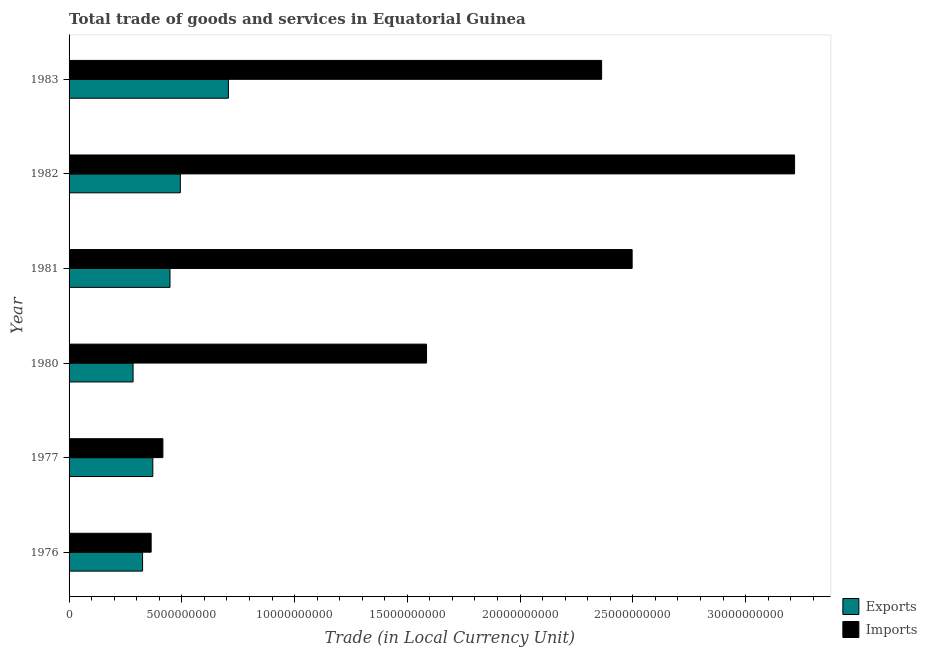How many groups of bars are there?
Your response must be concise. 6. How many bars are there on the 3rd tick from the top?
Ensure brevity in your answer.  2. What is the label of the 5th group of bars from the top?
Offer a very short reply. 1977. In how many cases, is the number of bars for a given year not equal to the number of legend labels?
Offer a very short reply. 0. What is the export of goods and services in 1977?
Keep it short and to the point. 3.71e+09. Across all years, what is the maximum export of goods and services?
Keep it short and to the point. 7.07e+09. Across all years, what is the minimum imports of goods and services?
Make the answer very short. 3.64e+09. In which year was the imports of goods and services minimum?
Your answer should be compact. 1976. What is the total export of goods and services in the graph?
Your response must be concise. 2.63e+1. What is the difference between the export of goods and services in 1976 and that in 1983?
Your answer should be compact. -3.81e+09. What is the difference between the imports of goods and services in 1983 and the export of goods and services in 1982?
Keep it short and to the point. 1.87e+1. What is the average export of goods and services per year?
Offer a very short reply. 4.38e+09. In the year 1981, what is the difference between the imports of goods and services and export of goods and services?
Provide a succinct answer. 2.05e+1. In how many years, is the imports of goods and services greater than 32000000000 LCU?
Your answer should be compact. 1. What is the ratio of the export of goods and services in 1976 to that in 1980?
Provide a succinct answer. 1.15. Is the export of goods and services in 1976 less than that in 1981?
Offer a terse response. Yes. Is the difference between the imports of goods and services in 1976 and 1981 greater than the difference between the export of goods and services in 1976 and 1981?
Give a very brief answer. No. What is the difference between the highest and the second highest export of goods and services?
Give a very brief answer. 2.13e+09. What is the difference between the highest and the lowest export of goods and services?
Provide a succinct answer. 4.23e+09. What does the 2nd bar from the top in 1977 represents?
Provide a succinct answer. Exports. What does the 1st bar from the bottom in 1980 represents?
Your answer should be very brief. Exports. Are all the bars in the graph horizontal?
Keep it short and to the point. Yes. Does the graph contain any zero values?
Offer a very short reply. No. Does the graph contain grids?
Your response must be concise. No. Where does the legend appear in the graph?
Offer a terse response. Bottom right. How are the legend labels stacked?
Offer a very short reply. Vertical. What is the title of the graph?
Your response must be concise. Total trade of goods and services in Equatorial Guinea. Does "Resident workers" appear as one of the legend labels in the graph?
Provide a short and direct response. No. What is the label or title of the X-axis?
Provide a short and direct response. Trade (in Local Currency Unit). What is the Trade (in Local Currency Unit) in Exports in 1976?
Offer a very short reply. 3.26e+09. What is the Trade (in Local Currency Unit) in Imports in 1976?
Provide a succinct answer. 3.64e+09. What is the Trade (in Local Currency Unit) in Exports in 1977?
Your answer should be very brief. 3.71e+09. What is the Trade (in Local Currency Unit) in Imports in 1977?
Keep it short and to the point. 4.16e+09. What is the Trade (in Local Currency Unit) in Exports in 1980?
Your answer should be compact. 2.84e+09. What is the Trade (in Local Currency Unit) of Imports in 1980?
Your response must be concise. 1.59e+1. What is the Trade (in Local Currency Unit) of Exports in 1981?
Provide a succinct answer. 4.48e+09. What is the Trade (in Local Currency Unit) in Imports in 1981?
Offer a terse response. 2.50e+1. What is the Trade (in Local Currency Unit) in Exports in 1982?
Ensure brevity in your answer.  4.93e+09. What is the Trade (in Local Currency Unit) in Imports in 1982?
Your answer should be compact. 3.22e+1. What is the Trade (in Local Currency Unit) of Exports in 1983?
Keep it short and to the point. 7.07e+09. What is the Trade (in Local Currency Unit) of Imports in 1983?
Your response must be concise. 2.36e+1. Across all years, what is the maximum Trade (in Local Currency Unit) in Exports?
Offer a terse response. 7.07e+09. Across all years, what is the maximum Trade (in Local Currency Unit) in Imports?
Your answer should be very brief. 3.22e+1. Across all years, what is the minimum Trade (in Local Currency Unit) in Exports?
Offer a terse response. 2.84e+09. Across all years, what is the minimum Trade (in Local Currency Unit) of Imports?
Give a very brief answer. 3.64e+09. What is the total Trade (in Local Currency Unit) of Exports in the graph?
Your answer should be very brief. 2.63e+1. What is the total Trade (in Local Currency Unit) in Imports in the graph?
Give a very brief answer. 1.04e+11. What is the difference between the Trade (in Local Currency Unit) of Exports in 1976 and that in 1977?
Provide a succinct answer. -4.54e+08. What is the difference between the Trade (in Local Currency Unit) in Imports in 1976 and that in 1977?
Provide a succinct answer. -5.21e+08. What is the difference between the Trade (in Local Currency Unit) in Exports in 1976 and that in 1980?
Offer a terse response. 4.21e+08. What is the difference between the Trade (in Local Currency Unit) of Imports in 1976 and that in 1980?
Provide a succinct answer. -1.22e+1. What is the difference between the Trade (in Local Currency Unit) in Exports in 1976 and that in 1981?
Provide a succinct answer. -1.22e+09. What is the difference between the Trade (in Local Currency Unit) of Imports in 1976 and that in 1981?
Make the answer very short. -2.13e+1. What is the difference between the Trade (in Local Currency Unit) in Exports in 1976 and that in 1982?
Your answer should be compact. -1.67e+09. What is the difference between the Trade (in Local Currency Unit) of Imports in 1976 and that in 1982?
Ensure brevity in your answer.  -2.85e+1. What is the difference between the Trade (in Local Currency Unit) of Exports in 1976 and that in 1983?
Your answer should be compact. -3.81e+09. What is the difference between the Trade (in Local Currency Unit) in Imports in 1976 and that in 1983?
Offer a very short reply. -2.00e+1. What is the difference between the Trade (in Local Currency Unit) in Exports in 1977 and that in 1980?
Offer a terse response. 8.75e+08. What is the difference between the Trade (in Local Currency Unit) in Imports in 1977 and that in 1980?
Give a very brief answer. -1.17e+1. What is the difference between the Trade (in Local Currency Unit) of Exports in 1977 and that in 1981?
Ensure brevity in your answer.  -7.62e+08. What is the difference between the Trade (in Local Currency Unit) in Imports in 1977 and that in 1981?
Your answer should be compact. -2.08e+1. What is the difference between the Trade (in Local Currency Unit) in Exports in 1977 and that in 1982?
Your answer should be compact. -1.22e+09. What is the difference between the Trade (in Local Currency Unit) in Imports in 1977 and that in 1982?
Offer a very short reply. -2.80e+1. What is the difference between the Trade (in Local Currency Unit) of Exports in 1977 and that in 1983?
Provide a succinct answer. -3.35e+09. What is the difference between the Trade (in Local Currency Unit) in Imports in 1977 and that in 1983?
Make the answer very short. -1.95e+1. What is the difference between the Trade (in Local Currency Unit) of Exports in 1980 and that in 1981?
Keep it short and to the point. -1.64e+09. What is the difference between the Trade (in Local Currency Unit) of Imports in 1980 and that in 1981?
Your answer should be very brief. -9.12e+09. What is the difference between the Trade (in Local Currency Unit) of Exports in 1980 and that in 1982?
Make the answer very short. -2.10e+09. What is the difference between the Trade (in Local Currency Unit) in Imports in 1980 and that in 1982?
Your answer should be compact. -1.63e+1. What is the difference between the Trade (in Local Currency Unit) in Exports in 1980 and that in 1983?
Your answer should be very brief. -4.23e+09. What is the difference between the Trade (in Local Currency Unit) of Imports in 1980 and that in 1983?
Give a very brief answer. -7.76e+09. What is the difference between the Trade (in Local Currency Unit) of Exports in 1981 and that in 1982?
Keep it short and to the point. -4.58e+08. What is the difference between the Trade (in Local Currency Unit) of Imports in 1981 and that in 1982?
Keep it short and to the point. -7.20e+09. What is the difference between the Trade (in Local Currency Unit) of Exports in 1981 and that in 1983?
Ensure brevity in your answer.  -2.59e+09. What is the difference between the Trade (in Local Currency Unit) in Imports in 1981 and that in 1983?
Provide a succinct answer. 1.35e+09. What is the difference between the Trade (in Local Currency Unit) in Exports in 1982 and that in 1983?
Your answer should be compact. -2.13e+09. What is the difference between the Trade (in Local Currency Unit) in Imports in 1982 and that in 1983?
Provide a short and direct response. 8.56e+09. What is the difference between the Trade (in Local Currency Unit) in Exports in 1976 and the Trade (in Local Currency Unit) in Imports in 1977?
Give a very brief answer. -9.01e+08. What is the difference between the Trade (in Local Currency Unit) of Exports in 1976 and the Trade (in Local Currency Unit) of Imports in 1980?
Your answer should be very brief. -1.26e+1. What is the difference between the Trade (in Local Currency Unit) in Exports in 1976 and the Trade (in Local Currency Unit) in Imports in 1981?
Provide a succinct answer. -2.17e+1. What is the difference between the Trade (in Local Currency Unit) of Exports in 1976 and the Trade (in Local Currency Unit) of Imports in 1982?
Your answer should be very brief. -2.89e+1. What is the difference between the Trade (in Local Currency Unit) of Exports in 1976 and the Trade (in Local Currency Unit) of Imports in 1983?
Provide a short and direct response. -2.04e+1. What is the difference between the Trade (in Local Currency Unit) in Exports in 1977 and the Trade (in Local Currency Unit) in Imports in 1980?
Offer a terse response. -1.21e+1. What is the difference between the Trade (in Local Currency Unit) of Exports in 1977 and the Trade (in Local Currency Unit) of Imports in 1981?
Provide a succinct answer. -2.13e+1. What is the difference between the Trade (in Local Currency Unit) of Exports in 1977 and the Trade (in Local Currency Unit) of Imports in 1982?
Your answer should be very brief. -2.85e+1. What is the difference between the Trade (in Local Currency Unit) of Exports in 1977 and the Trade (in Local Currency Unit) of Imports in 1983?
Provide a short and direct response. -1.99e+1. What is the difference between the Trade (in Local Currency Unit) of Exports in 1980 and the Trade (in Local Currency Unit) of Imports in 1981?
Provide a succinct answer. -2.21e+1. What is the difference between the Trade (in Local Currency Unit) of Exports in 1980 and the Trade (in Local Currency Unit) of Imports in 1982?
Make the answer very short. -2.93e+1. What is the difference between the Trade (in Local Currency Unit) in Exports in 1980 and the Trade (in Local Currency Unit) in Imports in 1983?
Provide a short and direct response. -2.08e+1. What is the difference between the Trade (in Local Currency Unit) of Exports in 1981 and the Trade (in Local Currency Unit) of Imports in 1982?
Ensure brevity in your answer.  -2.77e+1. What is the difference between the Trade (in Local Currency Unit) of Exports in 1981 and the Trade (in Local Currency Unit) of Imports in 1983?
Provide a succinct answer. -1.91e+1. What is the difference between the Trade (in Local Currency Unit) of Exports in 1982 and the Trade (in Local Currency Unit) of Imports in 1983?
Give a very brief answer. -1.87e+1. What is the average Trade (in Local Currency Unit) in Exports per year?
Make the answer very short. 4.38e+09. What is the average Trade (in Local Currency Unit) in Imports per year?
Your answer should be compact. 1.74e+1. In the year 1976, what is the difference between the Trade (in Local Currency Unit) of Exports and Trade (in Local Currency Unit) of Imports?
Keep it short and to the point. -3.80e+08. In the year 1977, what is the difference between the Trade (in Local Currency Unit) in Exports and Trade (in Local Currency Unit) in Imports?
Provide a succinct answer. -4.47e+08. In the year 1980, what is the difference between the Trade (in Local Currency Unit) in Exports and Trade (in Local Currency Unit) in Imports?
Make the answer very short. -1.30e+1. In the year 1981, what is the difference between the Trade (in Local Currency Unit) of Exports and Trade (in Local Currency Unit) of Imports?
Ensure brevity in your answer.  -2.05e+1. In the year 1982, what is the difference between the Trade (in Local Currency Unit) of Exports and Trade (in Local Currency Unit) of Imports?
Offer a very short reply. -2.72e+1. In the year 1983, what is the difference between the Trade (in Local Currency Unit) of Exports and Trade (in Local Currency Unit) of Imports?
Provide a succinct answer. -1.66e+1. What is the ratio of the Trade (in Local Currency Unit) in Exports in 1976 to that in 1977?
Keep it short and to the point. 0.88. What is the ratio of the Trade (in Local Currency Unit) of Imports in 1976 to that in 1977?
Keep it short and to the point. 0.87. What is the ratio of the Trade (in Local Currency Unit) of Exports in 1976 to that in 1980?
Make the answer very short. 1.15. What is the ratio of the Trade (in Local Currency Unit) in Imports in 1976 to that in 1980?
Give a very brief answer. 0.23. What is the ratio of the Trade (in Local Currency Unit) of Exports in 1976 to that in 1981?
Your answer should be compact. 0.73. What is the ratio of the Trade (in Local Currency Unit) in Imports in 1976 to that in 1981?
Keep it short and to the point. 0.15. What is the ratio of the Trade (in Local Currency Unit) of Exports in 1976 to that in 1982?
Your answer should be compact. 0.66. What is the ratio of the Trade (in Local Currency Unit) in Imports in 1976 to that in 1982?
Offer a terse response. 0.11. What is the ratio of the Trade (in Local Currency Unit) of Exports in 1976 to that in 1983?
Your answer should be compact. 0.46. What is the ratio of the Trade (in Local Currency Unit) of Imports in 1976 to that in 1983?
Make the answer very short. 0.15. What is the ratio of the Trade (in Local Currency Unit) of Exports in 1977 to that in 1980?
Your response must be concise. 1.31. What is the ratio of the Trade (in Local Currency Unit) of Imports in 1977 to that in 1980?
Provide a short and direct response. 0.26. What is the ratio of the Trade (in Local Currency Unit) of Exports in 1977 to that in 1981?
Your response must be concise. 0.83. What is the ratio of the Trade (in Local Currency Unit) of Imports in 1977 to that in 1981?
Ensure brevity in your answer.  0.17. What is the ratio of the Trade (in Local Currency Unit) of Exports in 1977 to that in 1982?
Keep it short and to the point. 0.75. What is the ratio of the Trade (in Local Currency Unit) in Imports in 1977 to that in 1982?
Offer a terse response. 0.13. What is the ratio of the Trade (in Local Currency Unit) in Exports in 1977 to that in 1983?
Provide a succinct answer. 0.53. What is the ratio of the Trade (in Local Currency Unit) of Imports in 1977 to that in 1983?
Keep it short and to the point. 0.18. What is the ratio of the Trade (in Local Currency Unit) of Exports in 1980 to that in 1981?
Your response must be concise. 0.63. What is the ratio of the Trade (in Local Currency Unit) in Imports in 1980 to that in 1981?
Give a very brief answer. 0.63. What is the ratio of the Trade (in Local Currency Unit) in Exports in 1980 to that in 1982?
Offer a terse response. 0.58. What is the ratio of the Trade (in Local Currency Unit) of Imports in 1980 to that in 1982?
Provide a short and direct response. 0.49. What is the ratio of the Trade (in Local Currency Unit) in Exports in 1980 to that in 1983?
Ensure brevity in your answer.  0.4. What is the ratio of the Trade (in Local Currency Unit) in Imports in 1980 to that in 1983?
Keep it short and to the point. 0.67. What is the ratio of the Trade (in Local Currency Unit) of Exports in 1981 to that in 1982?
Ensure brevity in your answer.  0.91. What is the ratio of the Trade (in Local Currency Unit) in Imports in 1981 to that in 1982?
Ensure brevity in your answer.  0.78. What is the ratio of the Trade (in Local Currency Unit) in Exports in 1981 to that in 1983?
Your response must be concise. 0.63. What is the ratio of the Trade (in Local Currency Unit) of Imports in 1981 to that in 1983?
Keep it short and to the point. 1.06. What is the ratio of the Trade (in Local Currency Unit) of Exports in 1982 to that in 1983?
Your answer should be compact. 0.7. What is the ratio of the Trade (in Local Currency Unit) in Imports in 1982 to that in 1983?
Offer a very short reply. 1.36. What is the difference between the highest and the second highest Trade (in Local Currency Unit) in Exports?
Your answer should be very brief. 2.13e+09. What is the difference between the highest and the second highest Trade (in Local Currency Unit) of Imports?
Offer a very short reply. 7.20e+09. What is the difference between the highest and the lowest Trade (in Local Currency Unit) in Exports?
Give a very brief answer. 4.23e+09. What is the difference between the highest and the lowest Trade (in Local Currency Unit) in Imports?
Make the answer very short. 2.85e+1. 